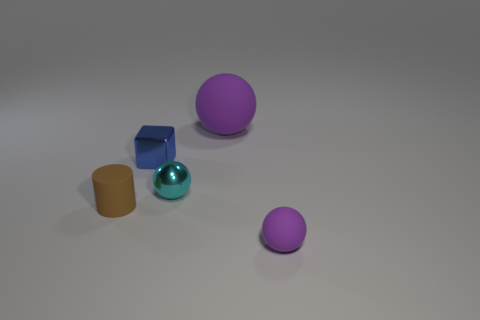Add 1 big purple rubber objects. How many objects exist? 6 Subtract all spheres. How many objects are left? 2 Subtract 0 purple cylinders. How many objects are left? 5 Subtract all tiny things. Subtract all tiny gray shiny cubes. How many objects are left? 1 Add 5 small brown matte cylinders. How many small brown matte cylinders are left? 6 Add 2 large purple rubber balls. How many large purple rubber balls exist? 3 